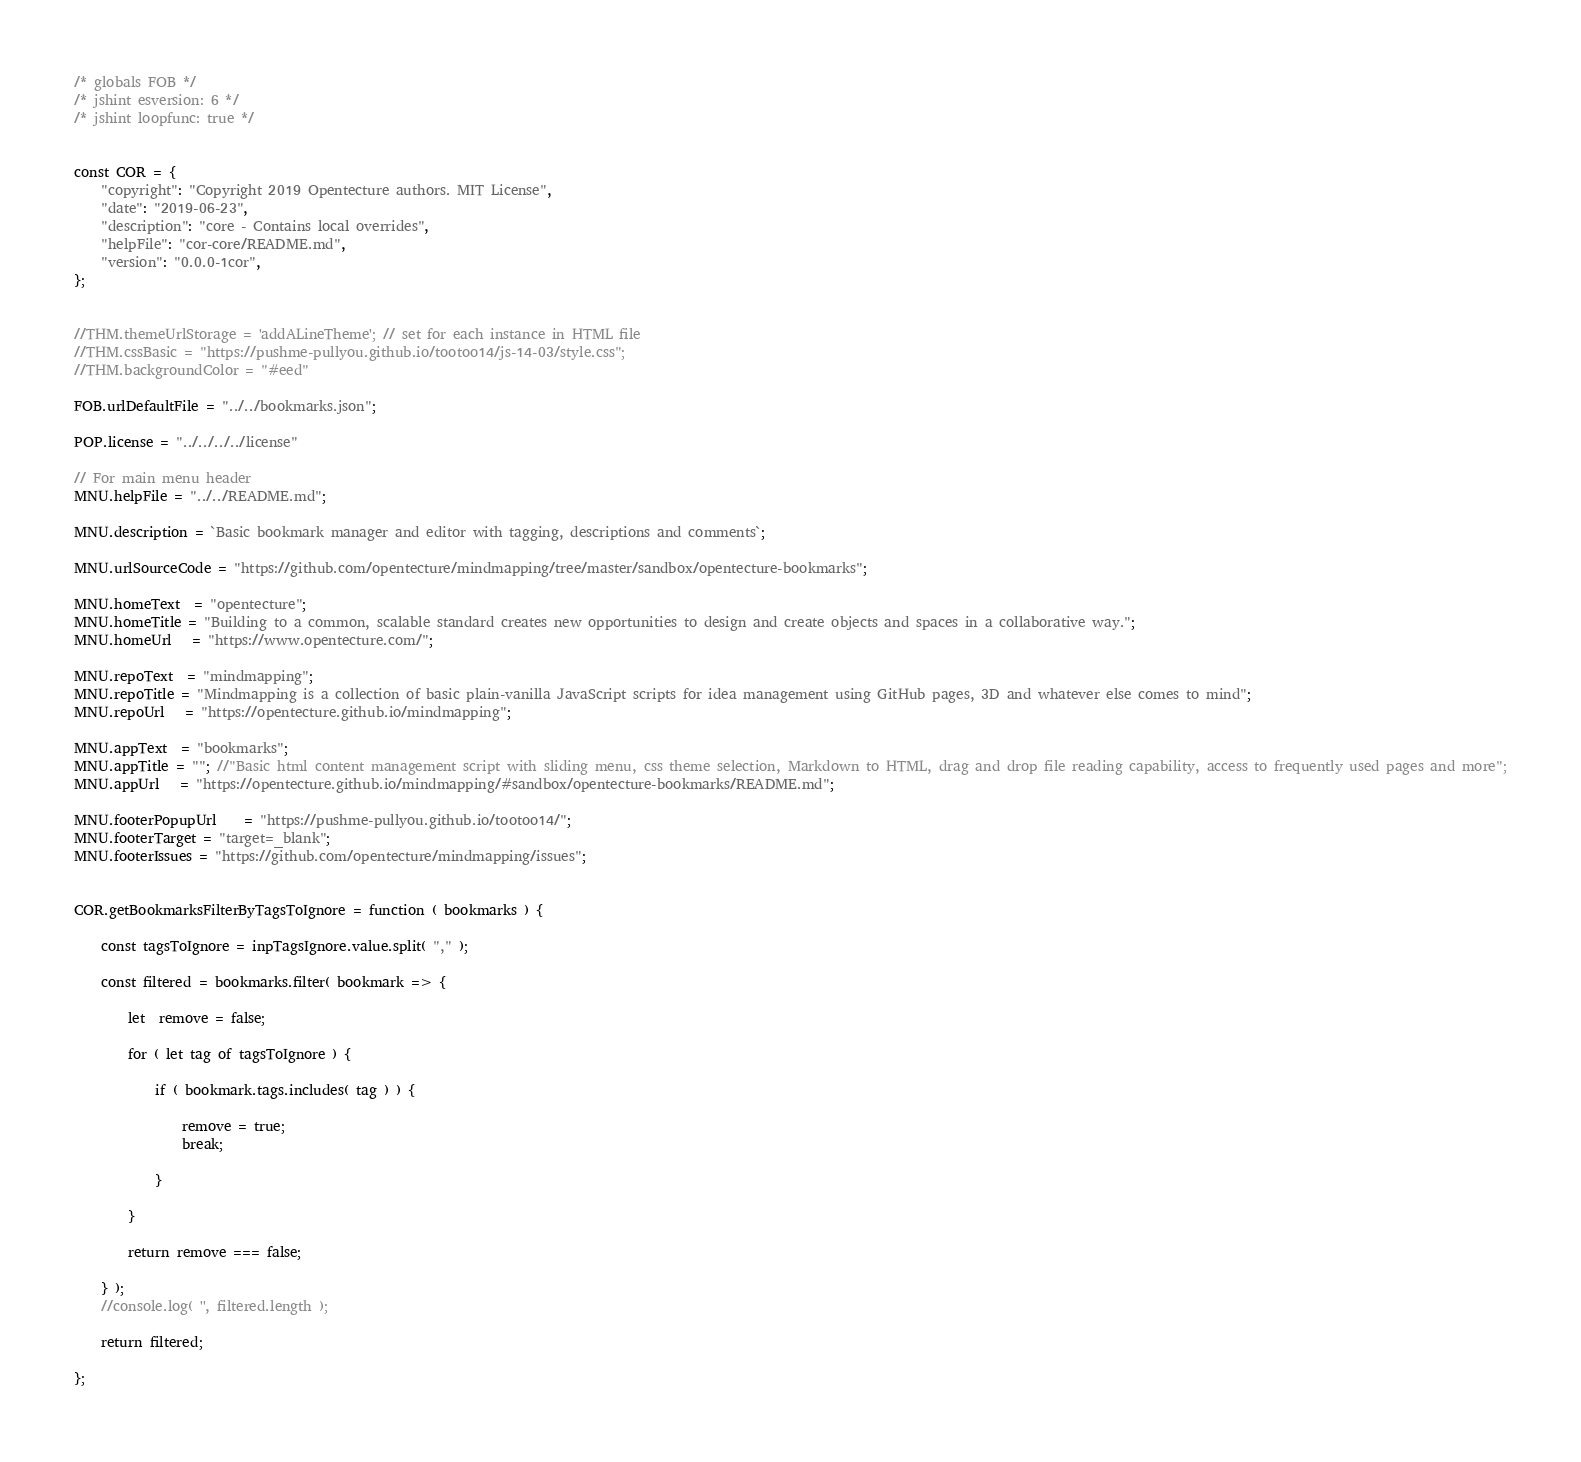<code> <loc_0><loc_0><loc_500><loc_500><_JavaScript_>/* globals FOB */
/* jshint esversion: 6 */
/* jshint loopfunc: true */


const COR = {
	"copyright": "Copyright 2019 Opentecture authors. MIT License",
	"date": "2019-06-23",
	"description": "core - Contains local overrides",
	"helpFile": "cor-core/README.md",
	"version": "0.0.0-1cor",
};


//THM.themeUrlStorage = 'addALineTheme'; // set for each instance in HTML file
//THM.cssBasic = "https://pushme-pullyou.github.io/tootoo14/js-14-03/style.css";
//THM.backgroundColor = "#eed"

FOB.urlDefaultFile = "../../bookmarks.json";

POP.license = "../../../../license"

// For main menu header
MNU.helpFile = "../../README.md";

MNU.description = `Basic bookmark manager and editor with tagging, descriptions and comments`;

MNU.urlSourceCode = "https://github.com/opentecture/mindmapping/tree/master/sandbox/opentecture-bookmarks";

MNU.homeText  = "opentecture";
MNU.homeTitle = "Building to a common, scalable standard creates new opportunities to design and create objects and spaces in a collaborative way.";
MNU.homeUrl   = "https://www.opentecture.com/";

MNU.repoText  = "mindmapping";
MNU.repoTitle = "Mindmapping is a collection of basic plain-vanilla JavaScript scripts for idea management using GitHub pages, 3D and whatever else comes to mind";
MNU.repoUrl   = "https://opentecture.github.io/mindmapping";

MNU.appText  = "bookmarks";
MNU.appTitle = ""; //"Basic html content management script with sliding menu, css theme selection, Markdown to HTML, drag and drop file reading capability, access to frequently used pages and more";
MNU.appUrl   = "https://opentecture.github.io/mindmapping/#sandbox/opentecture-bookmarks/README.md";

MNU.footerPopupUrl	= "https://pushme-pullyou.github.io/tootoo14/";
MNU.footerTarget = "target=_blank";
MNU.footerIssues = "https://github.com/opentecture/mindmapping/issues";


COR.getBookmarksFilterByTagsToIgnore = function ( bookmarks ) {

	const tagsToIgnore = inpTagsIgnore.value.split( "," );

	const filtered = bookmarks.filter( bookmark => {

		let  remove = false;

		for ( let tag of tagsToIgnore ) {

			if ( bookmark.tags.includes( tag ) ) {

				remove = true;
				break;

			}

		}

		return remove === false;

	} );
	//console.log( '', filtered.length );

	return filtered;

};</code> 